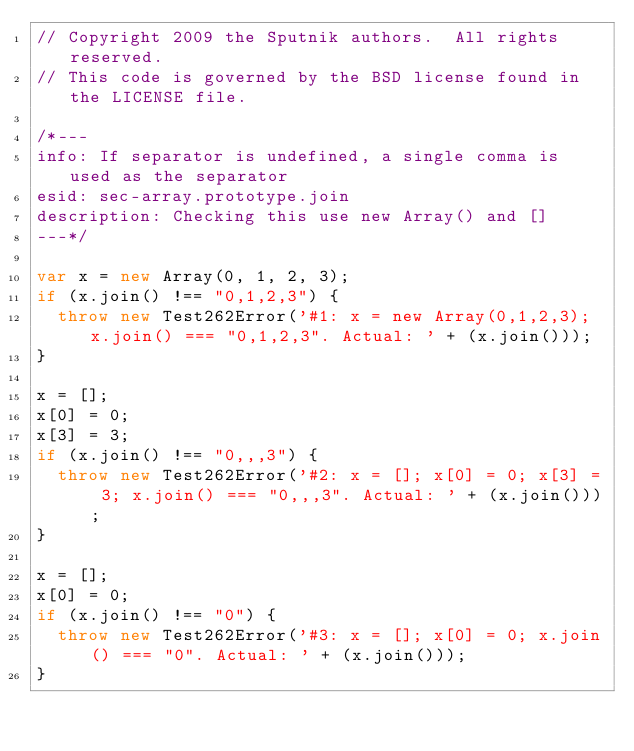<code> <loc_0><loc_0><loc_500><loc_500><_JavaScript_>// Copyright 2009 the Sputnik authors.  All rights reserved.
// This code is governed by the BSD license found in the LICENSE file.

/*---
info: If separator is undefined, a single comma is used as the separator
esid: sec-array.prototype.join
description: Checking this use new Array() and []
---*/

var x = new Array(0, 1, 2, 3);
if (x.join() !== "0,1,2,3") {
  throw new Test262Error('#1: x = new Array(0,1,2,3); x.join() === "0,1,2,3". Actual: ' + (x.join()));
}

x = [];
x[0] = 0;
x[3] = 3;
if (x.join() !== "0,,,3") {
  throw new Test262Error('#2: x = []; x[0] = 0; x[3] = 3; x.join() === "0,,,3". Actual: ' + (x.join()));
}

x = [];
x[0] = 0;
if (x.join() !== "0") {
  throw new Test262Error('#3: x = []; x[0] = 0; x.join() === "0". Actual: ' + (x.join()));
}
</code> 